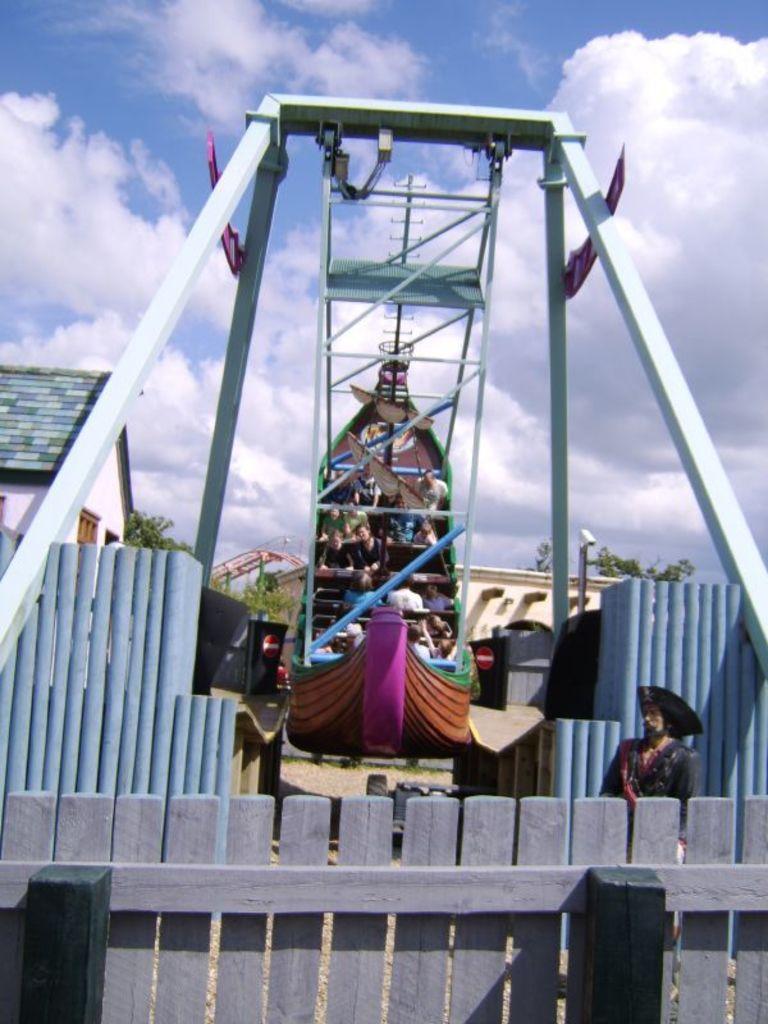Could you give a brief overview of what you see in this image? In this picture I can see a number of people in the amusement park ride. I can see clouds in the sky. I can see wooden fence. 